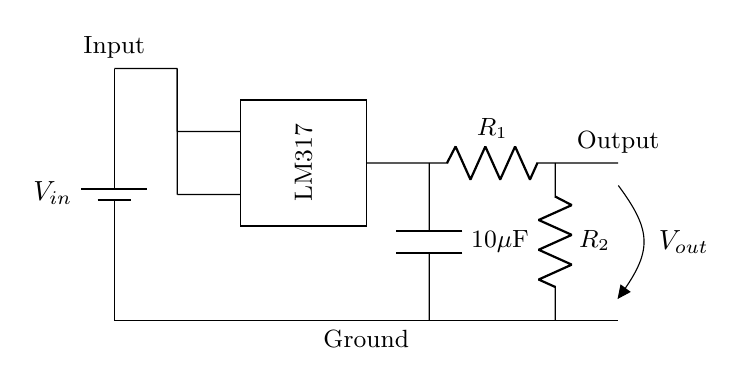What is the input component for this circuit? The input component is a battery, as indicated by the symbol for a battery (battery1) in the diagram providing the input voltage labeled as V_in.
Answer: Battery What type of voltage regulator is used in this circuit? The voltage regulator used is the LM317, which is explicitly labeled within the rectangle that represents the integrated circuit in the diagram.
Answer: LM317 What is the purpose of the capacitors in this circuit? The capacitor, shown in this circuit, is used to smooth out the output voltage by filtering any voltage spikes or dips, providing stability for the output voltage.
Answer: Smoothing What is the relationship between R1 and R2 in this voltage regulator? R1 and R2 form a voltage divider network that sets the output voltage level of the LM317; the values of these resistors are crucial in determining the output voltage based on the LM317 regulation principles.
Answer: Voltage division What is the output voltage label in the circuit? The output voltage is labeled as V_out, indicating where the stabilized voltage is derived from after passing through the voltage regulator and additional components.
Answer: V_out How many resistors are present in this circuit? There are two resistors present in the circuit, denoted as R1 and R2, which are essential for the voltage regulation process.
Answer: Two What is the value of the output capacitor in this circuit? The output capacitor is labeled as 10 microfarads (10μF), specified within the circuit diagram to assist in stabilizing the output voltage.
Answer: 10 microfarads 